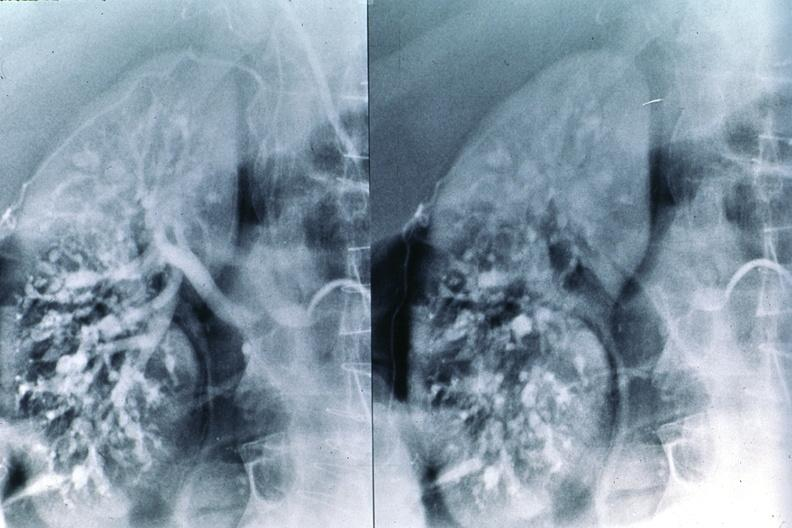what does this image show?
Answer the question using a single word or phrase. Polyarteritis nodosa 